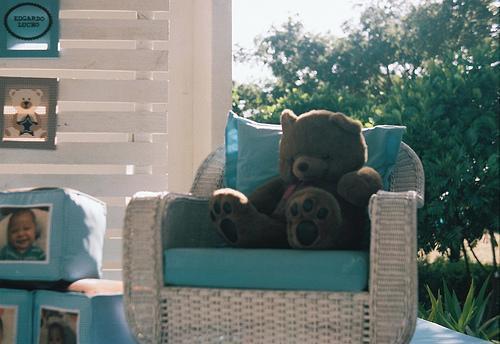How many fabric cubes are there?
Give a very brief answer. 3. 